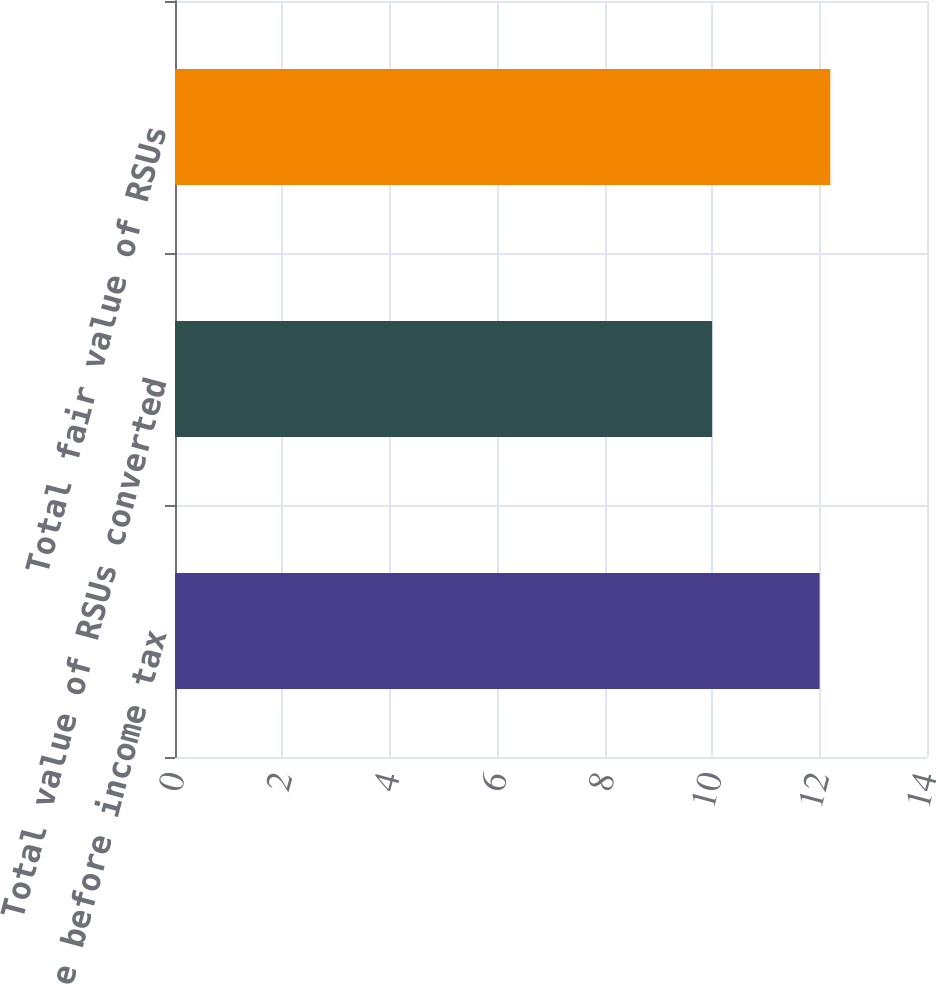Convert chart. <chart><loc_0><loc_0><loc_500><loc_500><bar_chart><fcel>RSU expense before income tax<fcel>Total value of RSUs converted<fcel>Total fair value of RSUs<nl><fcel>12<fcel>10<fcel>12.2<nl></chart> 